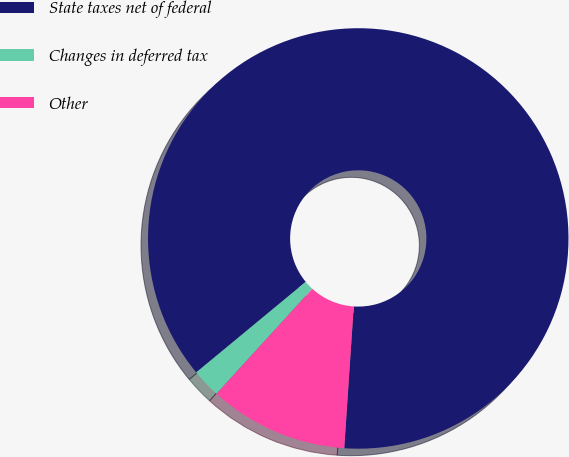Convert chart to OTSL. <chart><loc_0><loc_0><loc_500><loc_500><pie_chart><fcel>State taxes net of federal<fcel>Changes in deferred tax<fcel>Other<nl><fcel>87.05%<fcel>2.23%<fcel>10.71%<nl></chart> 